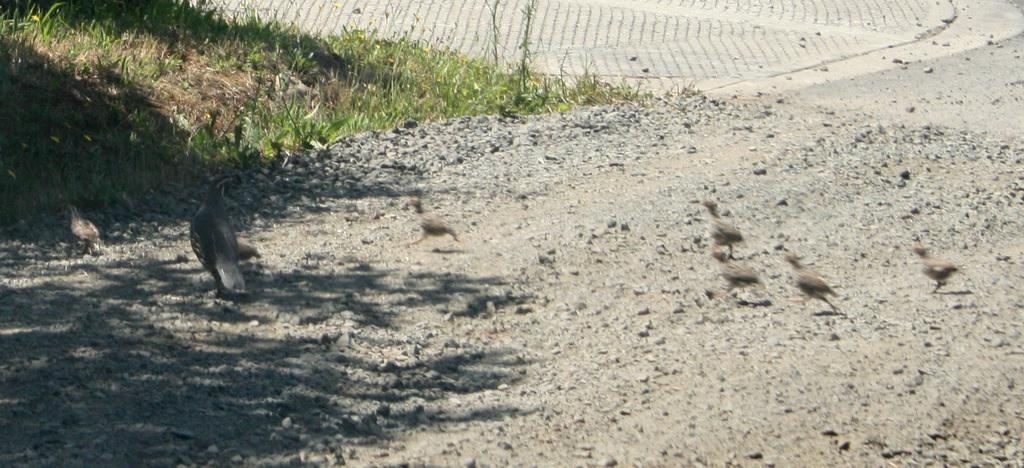What type of animals can be seen in the image? There are small birds in the image. What are the birds doing in the image? The birds are running on the ground. What type of vegetation is visible in the image? There are small grass plants visible in the image. What route do the birds take to reach the nearest muscle in the image? There is no muscle present in the image, and the birds are not shown traveling to any specific destination. 